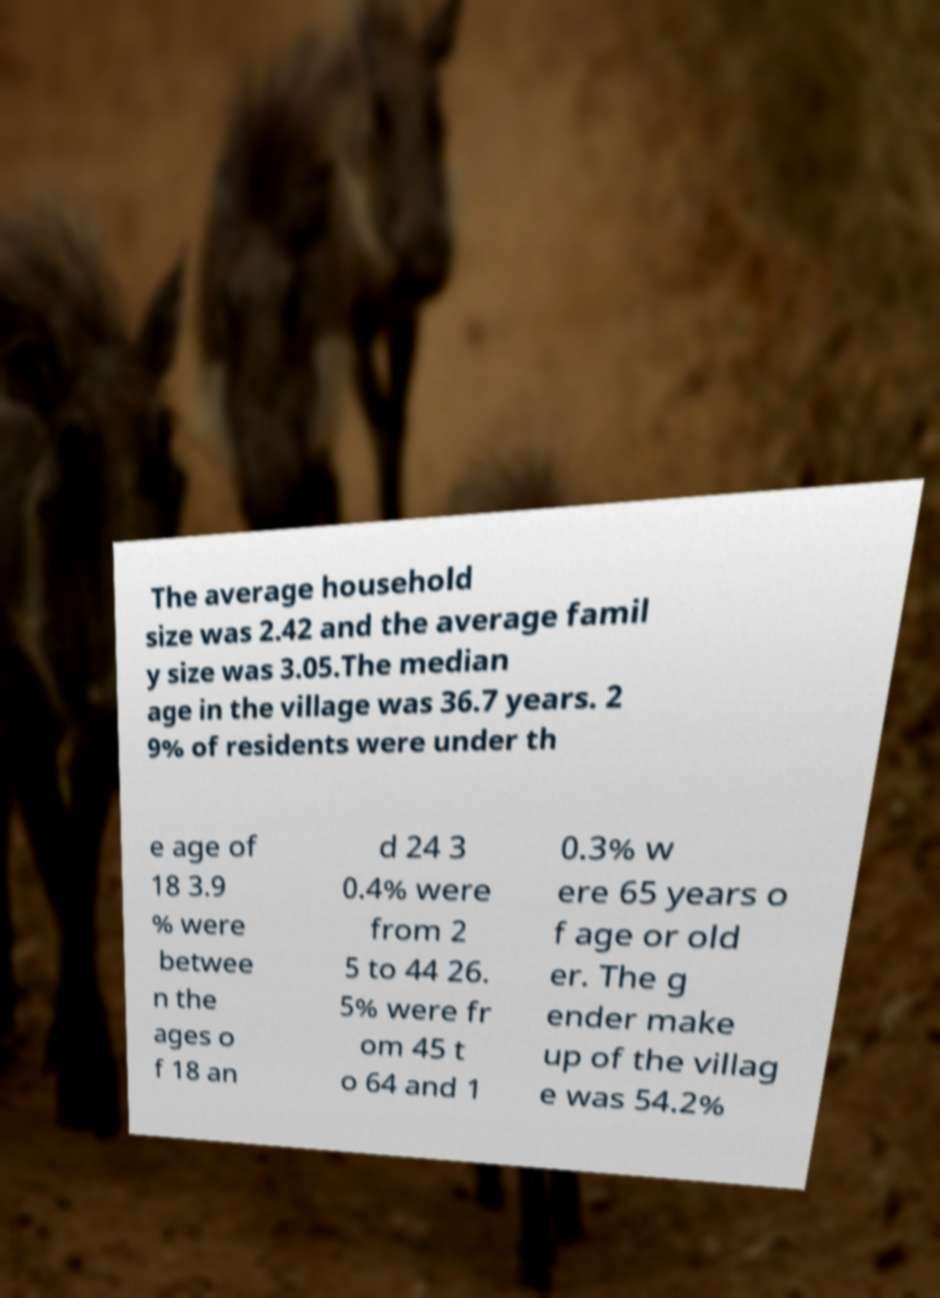Please identify and transcribe the text found in this image. The average household size was 2.42 and the average famil y size was 3.05.The median age in the village was 36.7 years. 2 9% of residents were under th e age of 18 3.9 % were betwee n the ages o f 18 an d 24 3 0.4% were from 2 5 to 44 26. 5% were fr om 45 t o 64 and 1 0.3% w ere 65 years o f age or old er. The g ender make up of the villag e was 54.2% 